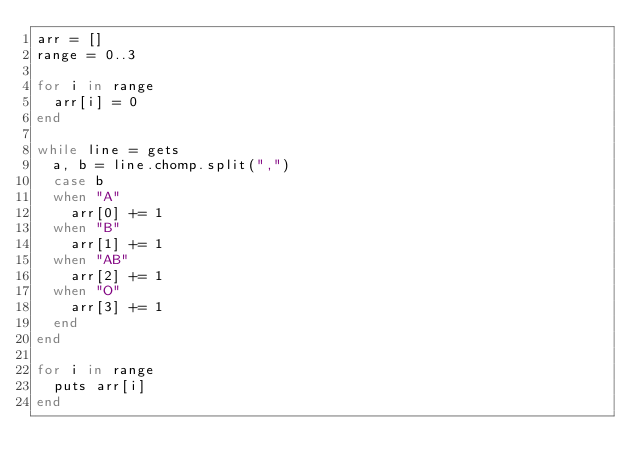<code> <loc_0><loc_0><loc_500><loc_500><_Ruby_>arr = []
range = 0..3

for i in range
  arr[i] = 0
end

while line = gets
  a, b = line.chomp.split(",")
  case b
  when "A"
    arr[0] += 1
  when "B"
    arr[1] += 1
  when "AB"
    arr[2] += 1
  when "O"
    arr[3] += 1
  end
end

for i in range
  puts arr[i]
end</code> 